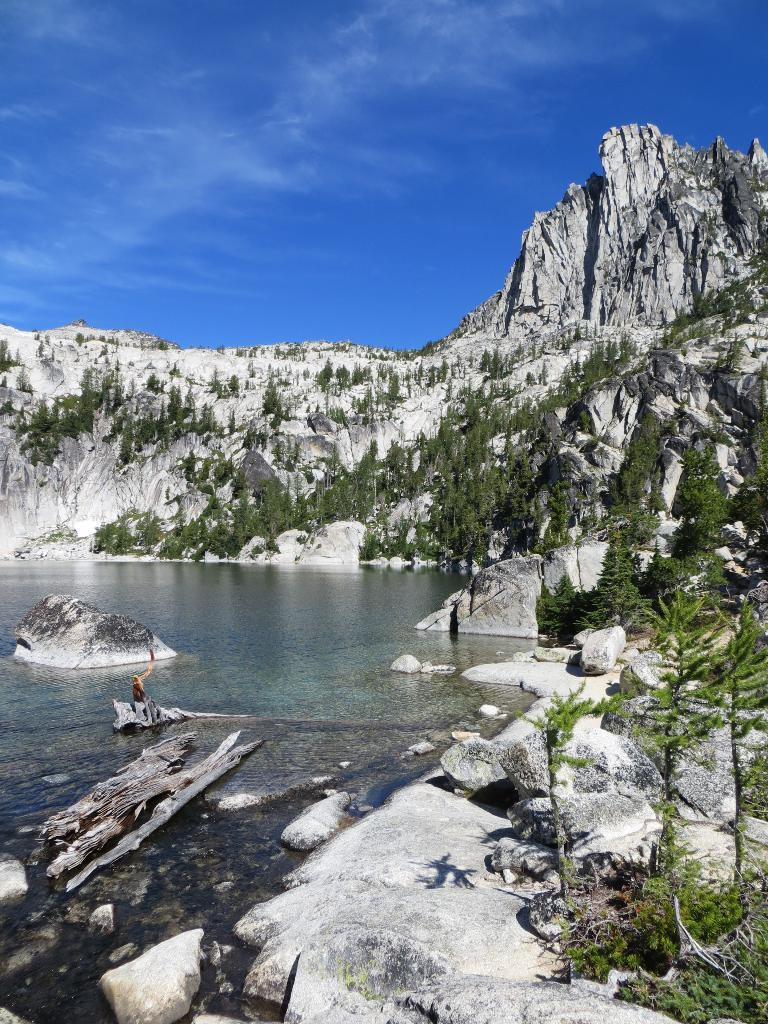What objects are in the water in the image? There are wooden trunks in the water in the image. What can be seen in the background of the image? There are trees, rocks, and clouds visible in the background of the image. Who is the creator of the foot that can be seen in the image? There is no foot present in the image, so it is not possible to determine who its creator might be. 